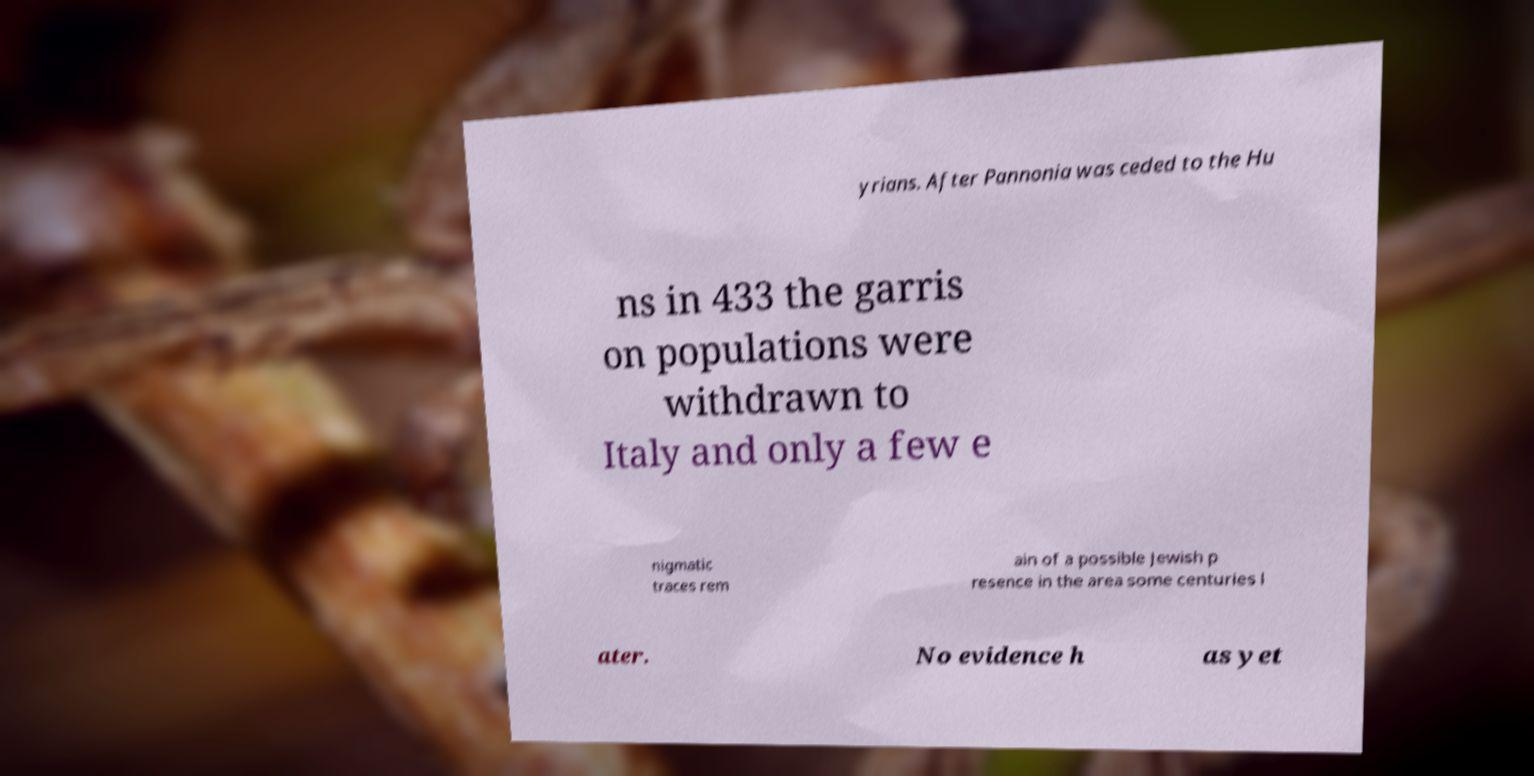I need the written content from this picture converted into text. Can you do that? yrians. After Pannonia was ceded to the Hu ns in 433 the garris on populations were withdrawn to Italy and only a few e nigmatic traces rem ain of a possible Jewish p resence in the area some centuries l ater. No evidence h as yet 